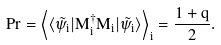Convert formula to latex. <formula><loc_0><loc_0><loc_500><loc_500>P r = \left < \langle \tilde { \psi } _ { i } | M _ { i } ^ { \dag } M _ { i } | \tilde { \psi } _ { i } \rangle \right > _ { i } = \frac { 1 + q } { 2 } .</formula> 